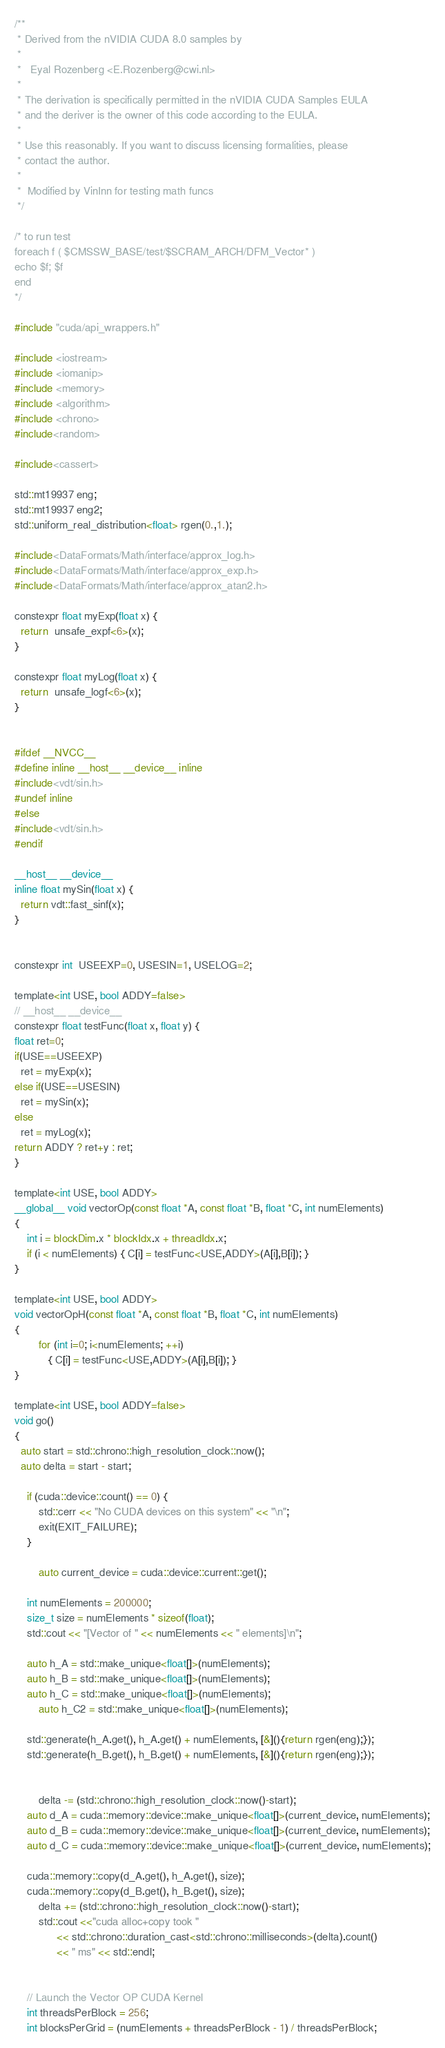<code> <loc_0><loc_0><loc_500><loc_500><_Cuda_>/**
 * Derived from the nVIDIA CUDA 8.0 samples by
 *
 *   Eyal Rozenberg <E.Rozenberg@cwi.nl>
 *
 * The derivation is specifically permitted in the nVIDIA CUDA Samples EULA
 * and the deriver is the owner of this code according to the EULA.
 *
 * Use this reasonably. If you want to discuss licensing formalities, please
 * contact the author.
 *
 *  Modified by VinInn for testing math funcs
 */

/* to run test
foreach f ( $CMSSW_BASE/test/$SCRAM_ARCH/DFM_Vector* )
echo $f; $f
end
*/

#include "cuda/api_wrappers.h"

#include <iostream>
#include <iomanip>
#include <memory>
#include <algorithm>
#include <chrono>
#include<random>

#include<cassert>

std::mt19937 eng;
std::mt19937 eng2;
std::uniform_real_distribution<float> rgen(0.,1.);

#include<DataFormats/Math/interface/approx_log.h>
#include<DataFormats/Math/interface/approx_exp.h>
#include<DataFormats/Math/interface/approx_atan2.h>

constexpr float myExp(float x) {
  return  unsafe_expf<6>(x);
}

constexpr float myLog(float x) {
  return  unsafe_logf<6>(x);
}


#ifdef __NVCC__
#define inline __host__ __device__ inline
#include<vdt/sin.h>
#undef inline
#else
#include<vdt/sin.h>
#endif

__host__ __device__
inline float mySin(float x) {
  return vdt::fast_sinf(x);
}


constexpr int  USEEXP=0, USESIN=1, USELOG=2;

template<int USE, bool ADDY=false>
// __host__ __device__
constexpr float testFunc(float x, float y) {
float ret=0;
if(USE==USEEXP)
  ret = myExp(x);
else if(USE==USESIN)
  ret = mySin(x);
else
  ret = myLog(x);
return ADDY ? ret+y : ret;
}

template<int USE, bool ADDY>
__global__ void vectorOp(const float *A, const float *B, float *C, int numElements)
{
	int i = blockDim.x * blockIdx.x + threadIdx.x;
	if (i < numElements) { C[i] = testFunc<USE,ADDY>(A[i],B[i]); }
}

template<int USE, bool ADDY>
void vectorOpH(const float *A, const float *B, float *C, int numElements)
{
        for (int i=0; i<numElements; ++i)
           { C[i] = testFunc<USE,ADDY>(A[i],B[i]); }
}

template<int USE, bool ADDY=false>
void go()
{
  auto start = std::chrono::high_resolution_clock::now();
  auto delta = start - start;

	if (cuda::device::count() == 0) {
		std::cerr << "No CUDA devices on this system" << "\n";
		exit(EXIT_FAILURE);
	}

        auto current_device = cuda::device::current::get(); 

	int numElements = 200000;
	size_t size = numElements * sizeof(float);
	std::cout << "[Vector of " << numElements << " elements]\n";

	auto h_A = std::make_unique<float[]>(numElements);
	auto h_B = std::make_unique<float[]>(numElements);
	auto h_C = std::make_unique<float[]>(numElements);
        auto h_C2 = std::make_unique<float[]>(numElements);

	std::generate(h_A.get(), h_A.get() + numElements, [&](){return rgen(eng);});
	std::generate(h_B.get(), h_B.get() + numElements, [&](){return rgen(eng);});


        delta -= (std::chrono::high_resolution_clock::now()-start);
	auto d_A = cuda::memory::device::make_unique<float[]>(current_device, numElements);
	auto d_B = cuda::memory::device::make_unique<float[]>(current_device, numElements);
	auto d_C = cuda::memory::device::make_unique<float[]>(current_device, numElements);

	cuda::memory::copy(d_A.get(), h_A.get(), size);
	cuda::memory::copy(d_B.get(), h_B.get(), size);
        delta += (std::chrono::high_resolution_clock::now()-start);
        std::cout <<"cuda alloc+copy took "
              << std::chrono::duration_cast<std::chrono::milliseconds>(delta).count()
              << " ms" << std::endl;


	// Launch the Vector OP CUDA Kernel
	int threadsPerBlock = 256;
	int blocksPerGrid = (numElements + threadsPerBlock - 1) / threadsPerBlock;</code> 